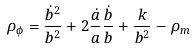<formula> <loc_0><loc_0><loc_500><loc_500>\rho _ { \phi } = \frac { \dot { b } ^ { 2 } } { b ^ { 2 } } + 2 \frac { \dot { a } } { a } \frac { \dot { b } } { b } + \frac { k } { b ^ { 2 } } - \rho _ { m }</formula> 